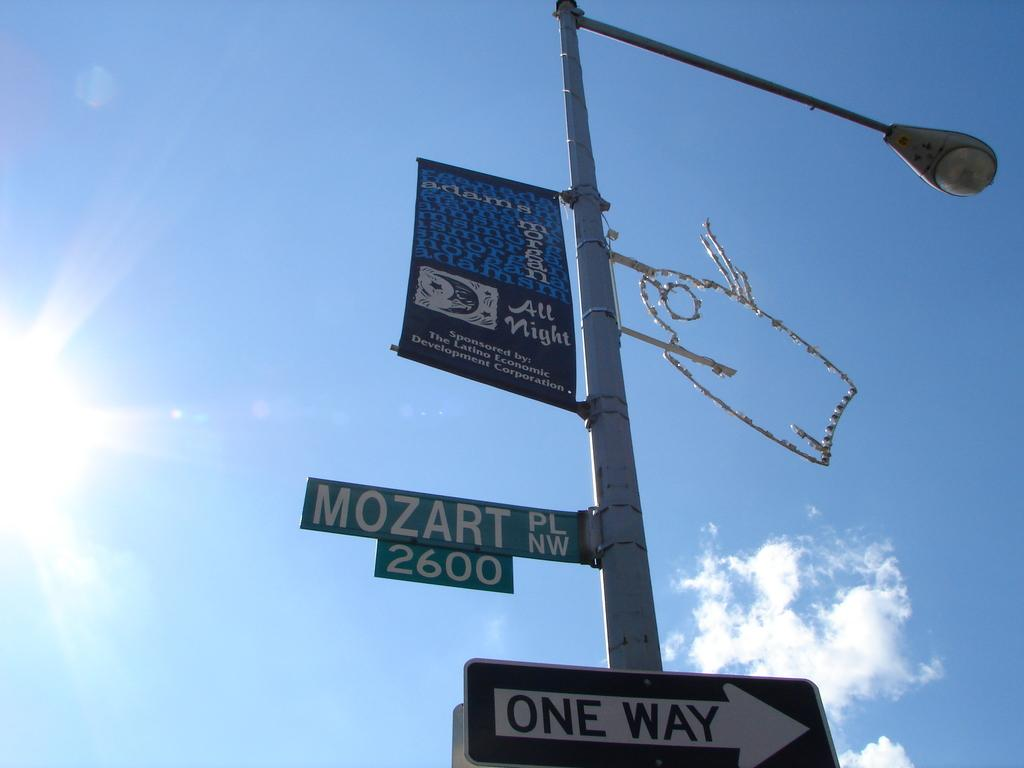Provide a one-sentence caption for the provided image. Decorated lamp post located at 2600 Mozart PL NW. 